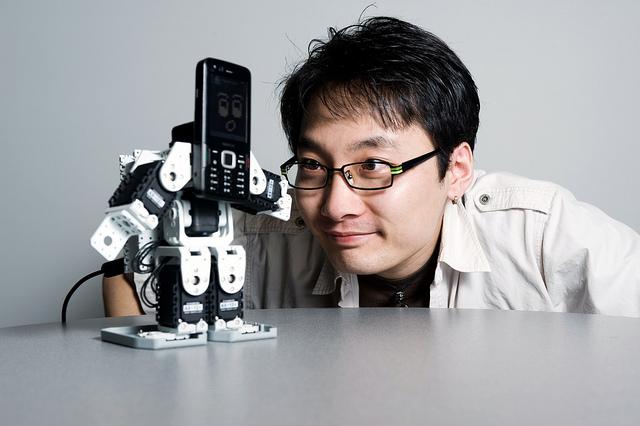What object is the robots face?
Give a very brief answer. Cell phone. Is the man a scientist?
Quick response, please. Yes. What's the man looking at?
Concise answer only. Robot. 